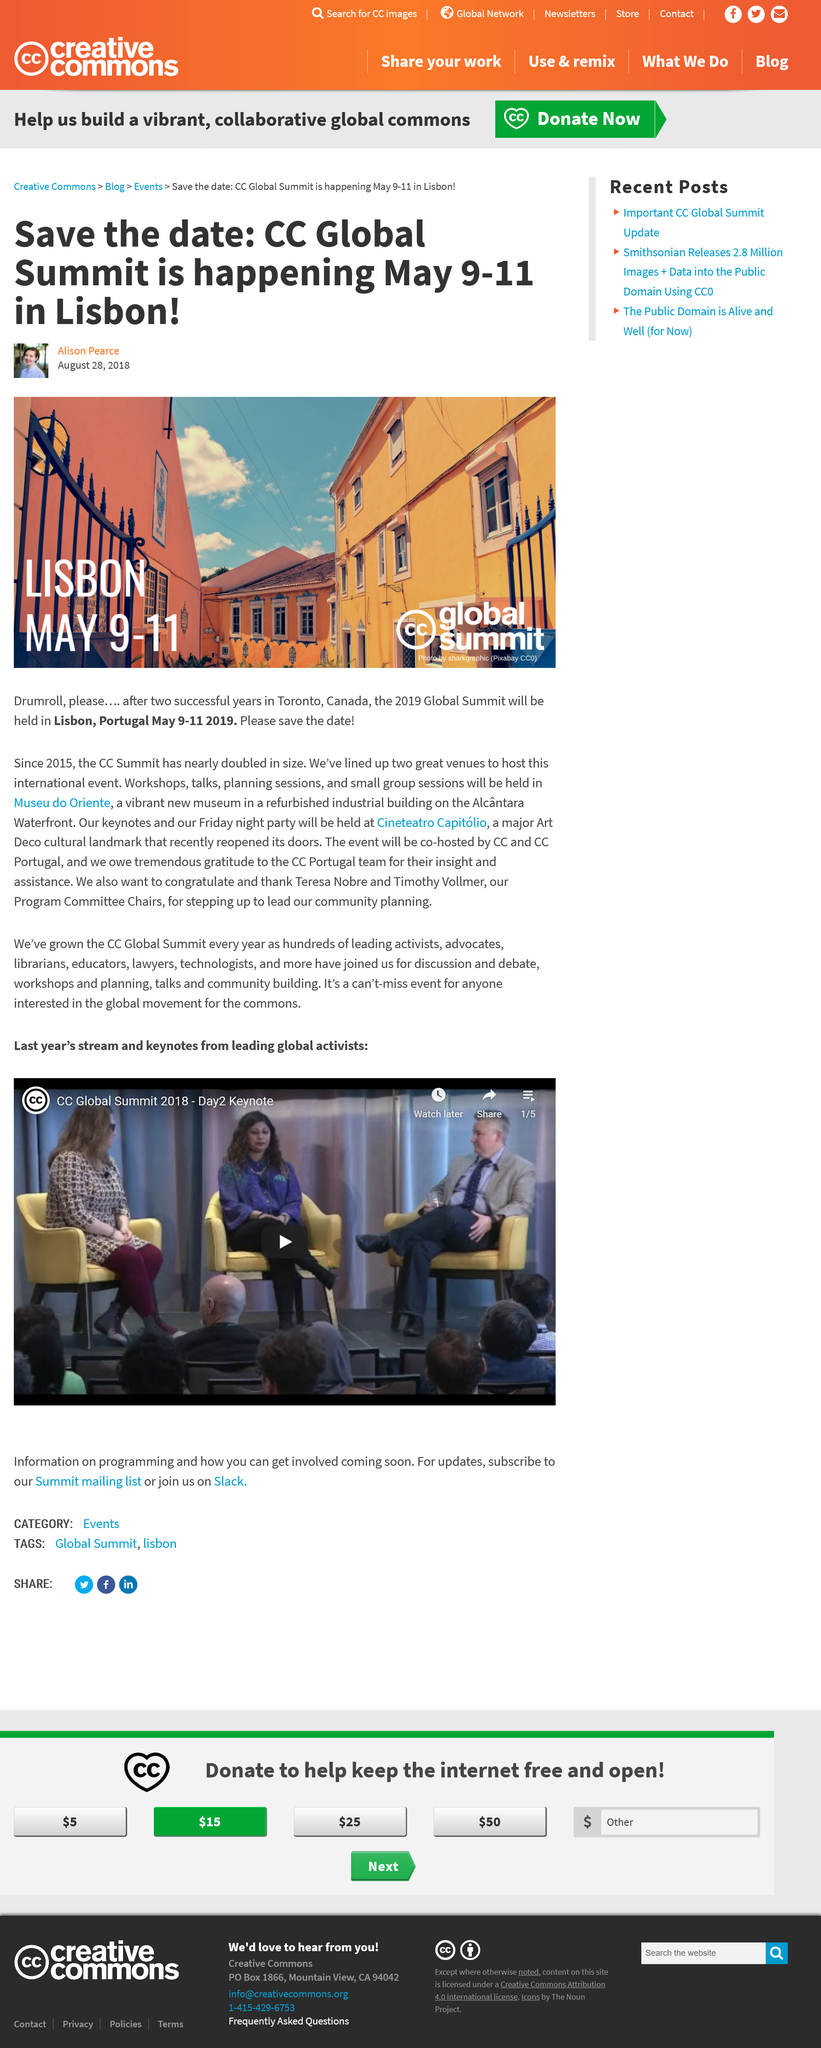List a handful of essential elements in this visual. The CC Global Summit is taking place in Lisbon in 2019. The co-hosts of the event are CC and CC Portugal. The CC Global Summits were held in Toronto in the last two occasions. 